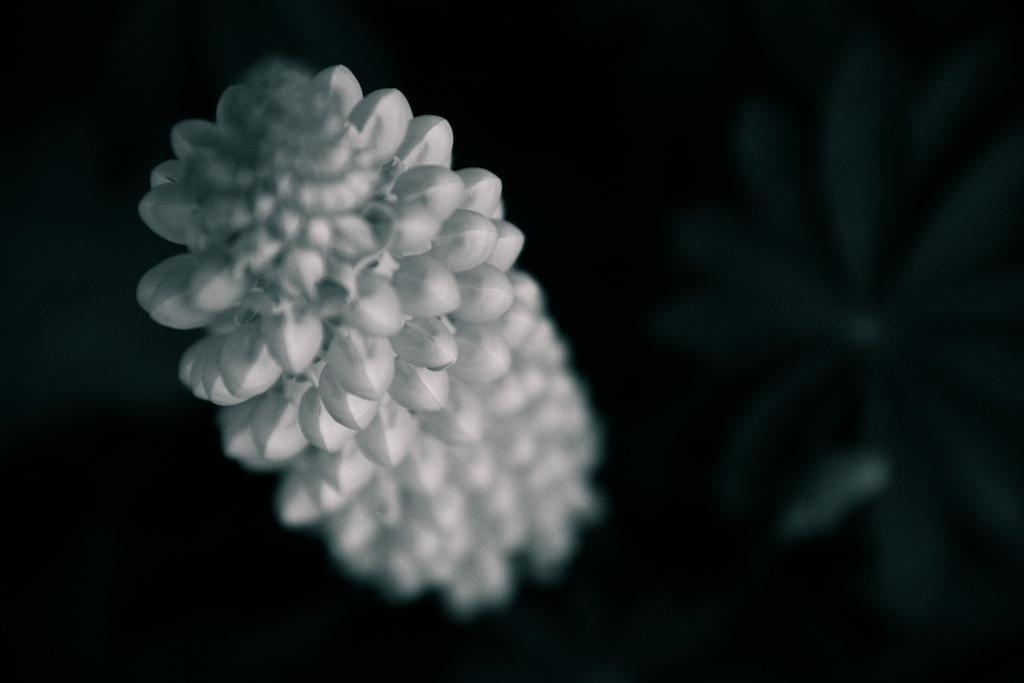What is the main subject in the center of the image? There is a white color object in the center of the image. What is the possible identity of the object? The object might be buds. How would you describe the surrounding area in the image? The area around the object is dark and blurred. What type of insect can be seen crawling on the buds in the image? A: There is no insect present in the image; it only features a white color object that might be buds. 